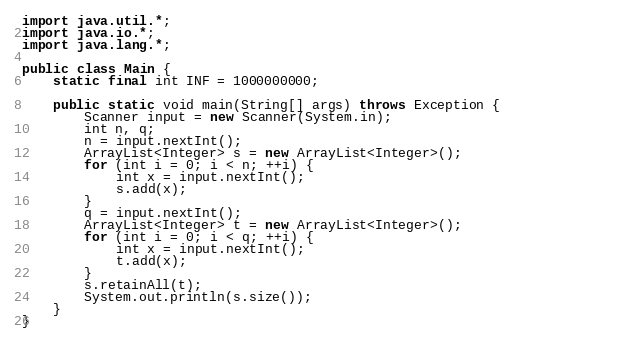<code> <loc_0><loc_0><loc_500><loc_500><_Java_>import java.util.*;
import java.io.*;
import java.lang.*;

public class Main {
    static final int INF = 1000000000;     
    
    public static void main(String[] args) throws Exception {                
        Scanner input = new Scanner(System.in);
        int n, q;
        n = input.nextInt();
        ArrayList<Integer> s = new ArrayList<Integer>();
        for (int i = 0; i < n; ++i) {
            int x = input.nextInt();
            s.add(x);
        }
        q = input.nextInt();
        ArrayList<Integer> t = new ArrayList<Integer>();
        for (int i = 0; i < q; ++i) {
            int x = input.nextInt();
            t.add(x);
        }
        s.retainAll(t);
        System.out.println(s.size());
    }                
}</code> 